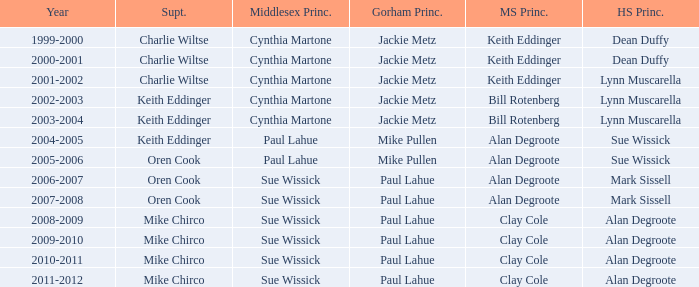How many high school principals were there in 2000-2001? Dean Duffy. 